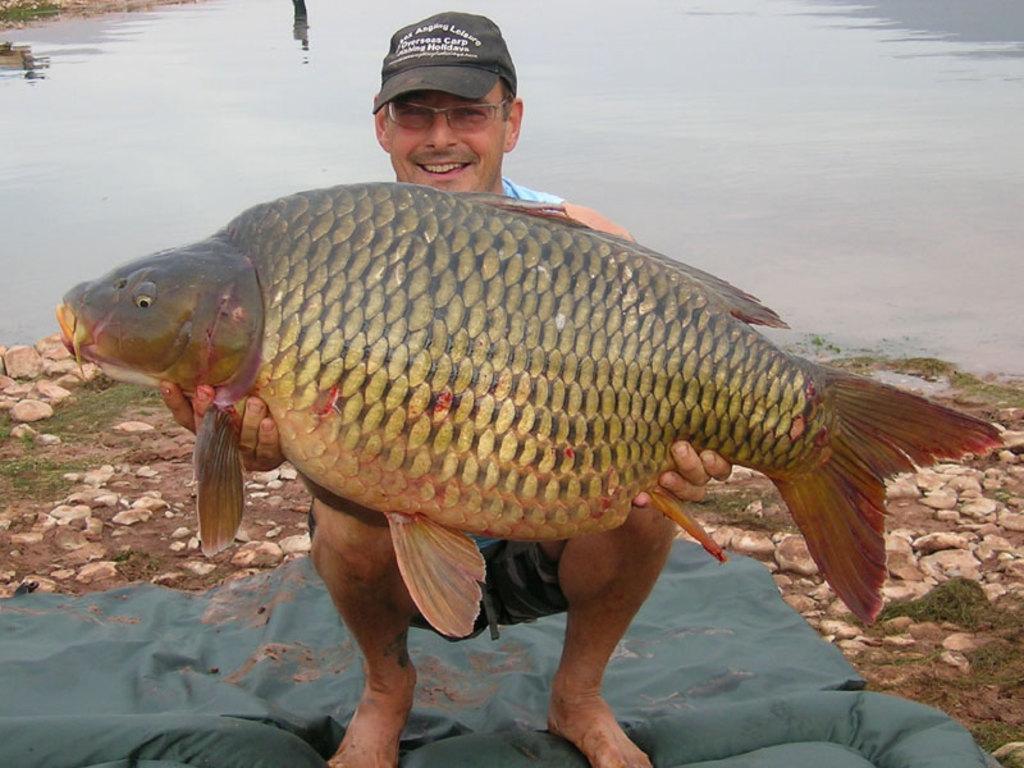Can you describe this image briefly? In the center of the image we can see a man is sitting on his knees and holding a fish and wearing cap, spectacles. In the background of the image we can see the water, stones and ground. At the bottom of the image we can see a tent. 